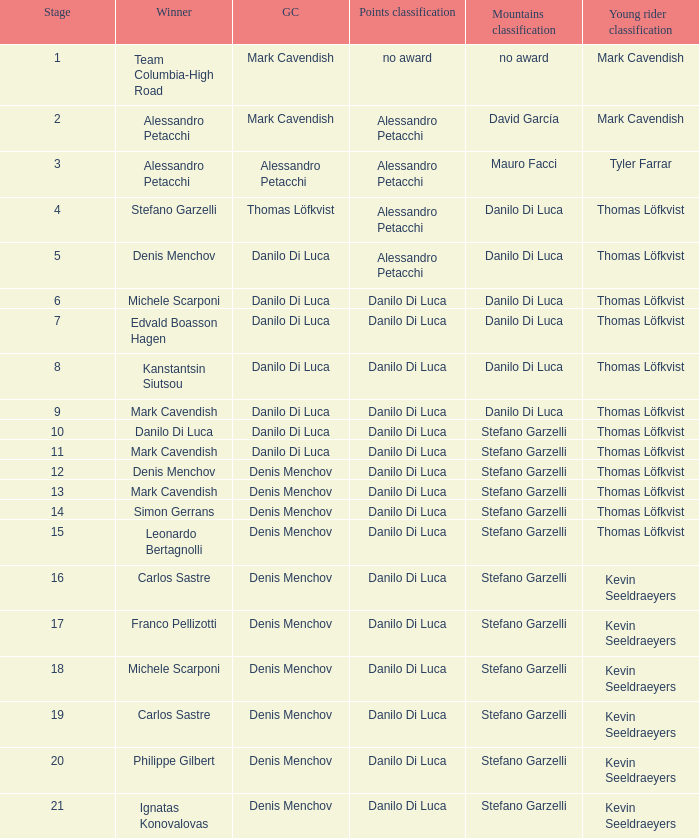When 19 is the stage who is the points classification? Danilo Di Luca. 